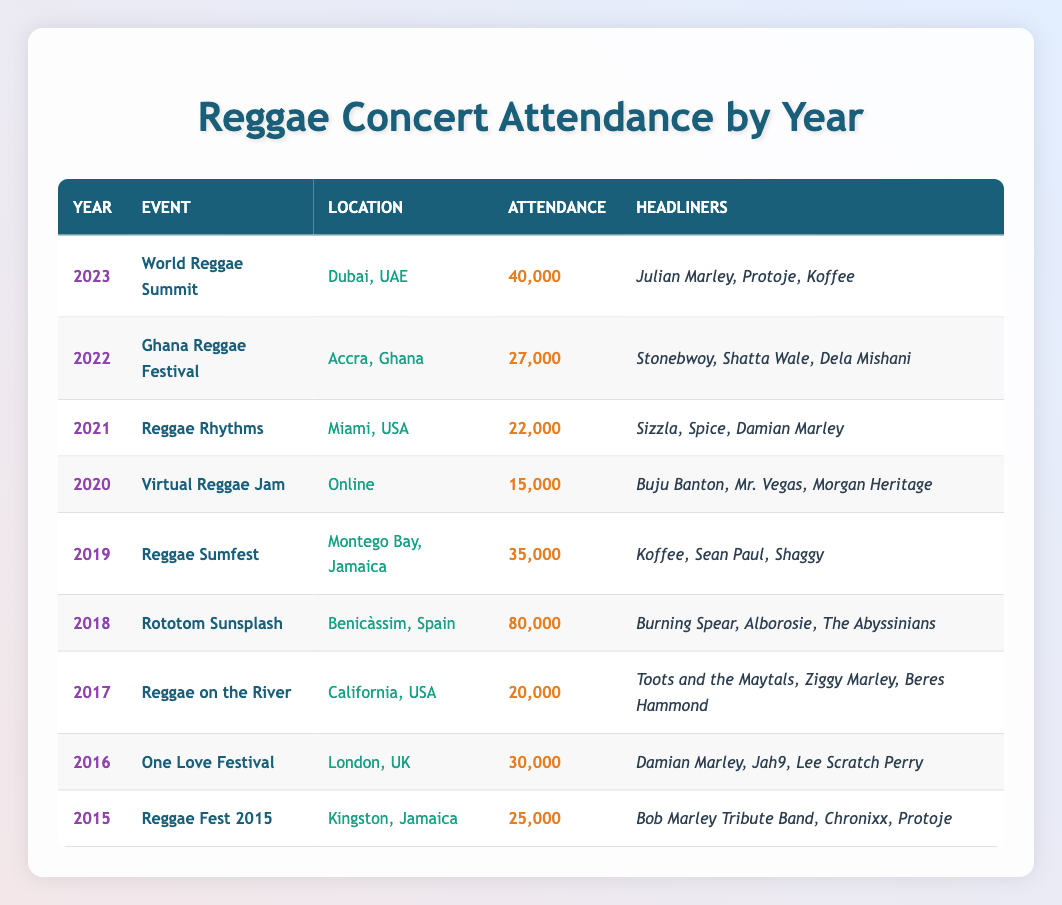What was the event with the highest attendance? By examining the attendance figures in the table, the event with the highest attendance is "Rototom Sunsplash" in 2018, which had 80,000 attendees.
Answer: Rototom Sunsplash How many attendees were at the Reggae Fest 2015? Looking at the table, the Reggae Fest 2015 had an attendance of 25,000.
Answer: 25,000 What is the total attendance over the years 2015 to 2019? To find the total attendance from 2015 to 2019, add the attendance figures: 25,000 + 30,000 + 20,000 + 35,000 = 110,000.
Answer: 110,000 Which year had the least concert attendance? The year with the least attendance is 2020, with an attendance of 15,000 for the "Virtual Reggae Jam."
Answer: 2020 Did the attendance increase from 2021 to 2022? To determine this, we check the attendance for both years: 2021 had 22,000 attendees and 2022 had 27,000 attendees. Since 27,000 is greater than 22,000, the attendance did increase.
Answer: Yes What is the average attendance over all the years listed? First, sum the attendance figures from all years: 25000 + 30000 + 20000 + 80000 + 35000 + 15000 + 22000 + 27000 + 40000 = 222000. Then there are 9 years, so the average is 222000 / 9 = 24666.67, which rounds to approximately 24667.
Answer: 24667 Which event took place in California in 2017? Referring to the table, the event that took place in California in 2017 is "Reggae on the River."
Answer: Reggae on the River Compare the attendance of 2018 and 2023. Did 2023 have more or less attendees? In 2018, the attendance was 80,000 for "Rototom Sunsplash," while in 2023, the attendance was 40,000 for the "World Reggae Summit." Since 80,000 > 40,000, 2023 had less attendance than 2018.
Answer: Less What percentage of attendees in 2020 joined compared to the previous year? The attendance in 2020 was 15,000, and in 2021 it was 22,000. To find the percentage, calculate: (15,000 / 22,000) * 100 = 68.18%.
Answer: 68.18% Which location hosted the "One Love Festival"? According to the table, the "One Love Festival" was hosted in London, UK.
Answer: London, UK Did any year see an attendance above 70,000? By checking the attendance figures in the table, only 2018 with "Rototom Sunsplash," which had 80,000 attendees, is above 70,000.
Answer: Yes 